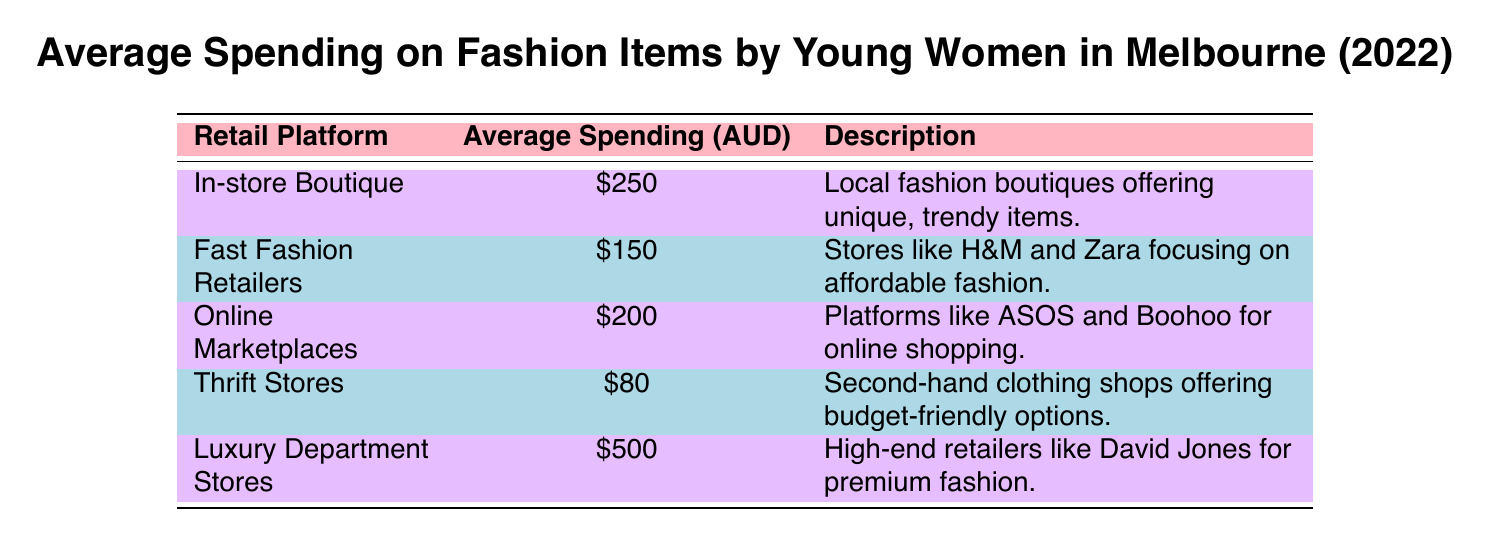What is the average spending on fashion items at luxury department stores? The table indicates that the average spending at luxury department stores is $500, which is explicitly stated in the data for that retail platform.
Answer: 500 Which retail platform has the lowest average spending? According to the table, thrift stores have the lowest average spending at $80, as the values listed for other retail platforms are all higher than this amount.
Answer: 80 What is the total average spending on fashion items by young women in Melbourne across all listed platforms? By summing the average spending amounts: 250 (in-store boutique) + 150 (fast fashion retailers) + 200 (online marketplaces) + 80 (thrift stores) + 500 (luxury department stores) = 1180. The total average spending is therefore $1180.
Answer: 1180 Is the average spending at online marketplaces more than that at fast fashion retailers? The average spending at online marketplaces is $200, and at fast fashion retailers, it is $150. Since $200 is greater than $150, the statement is true.
Answer: Yes What is the average spending difference between luxury department stores and thrift stores? The average spending for luxury department stores is $500, while thrift stores have an average spending of $80. To find the difference, subtract the smaller from the larger: 500 - 80 = 420. So, the average spending difference is $420.
Answer: 420 